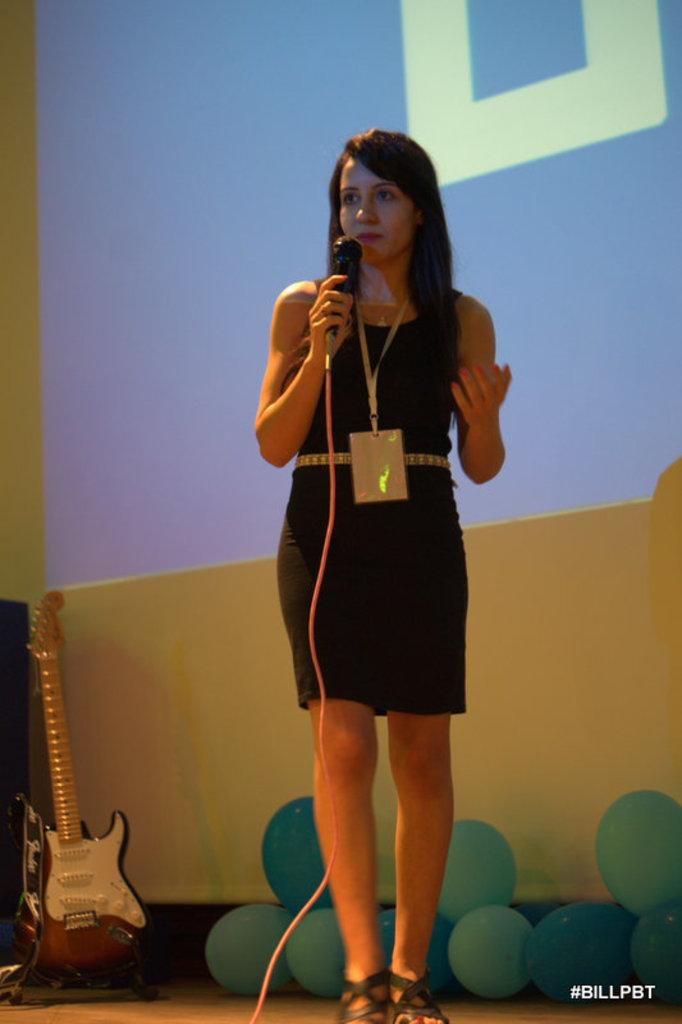Who is the main subject in the image? There is a woman in the image. What is the woman doing in the image? The woman is standing in the image. What object is the woman holding in the image? The woman is holding a microphone in the image. What musical instrument can be seen in the image? There is a guitar in the image. What additional decorative elements are present in the image? There are balloons in the image. What is the woman's tendency to walk in the image? The image does not provide information about the woman's tendency to walk, as she is standing and not walking. How many feet are visible in the image? The image does not show any feet, as it focuses on the woman's upper body and the objects she is holding. 